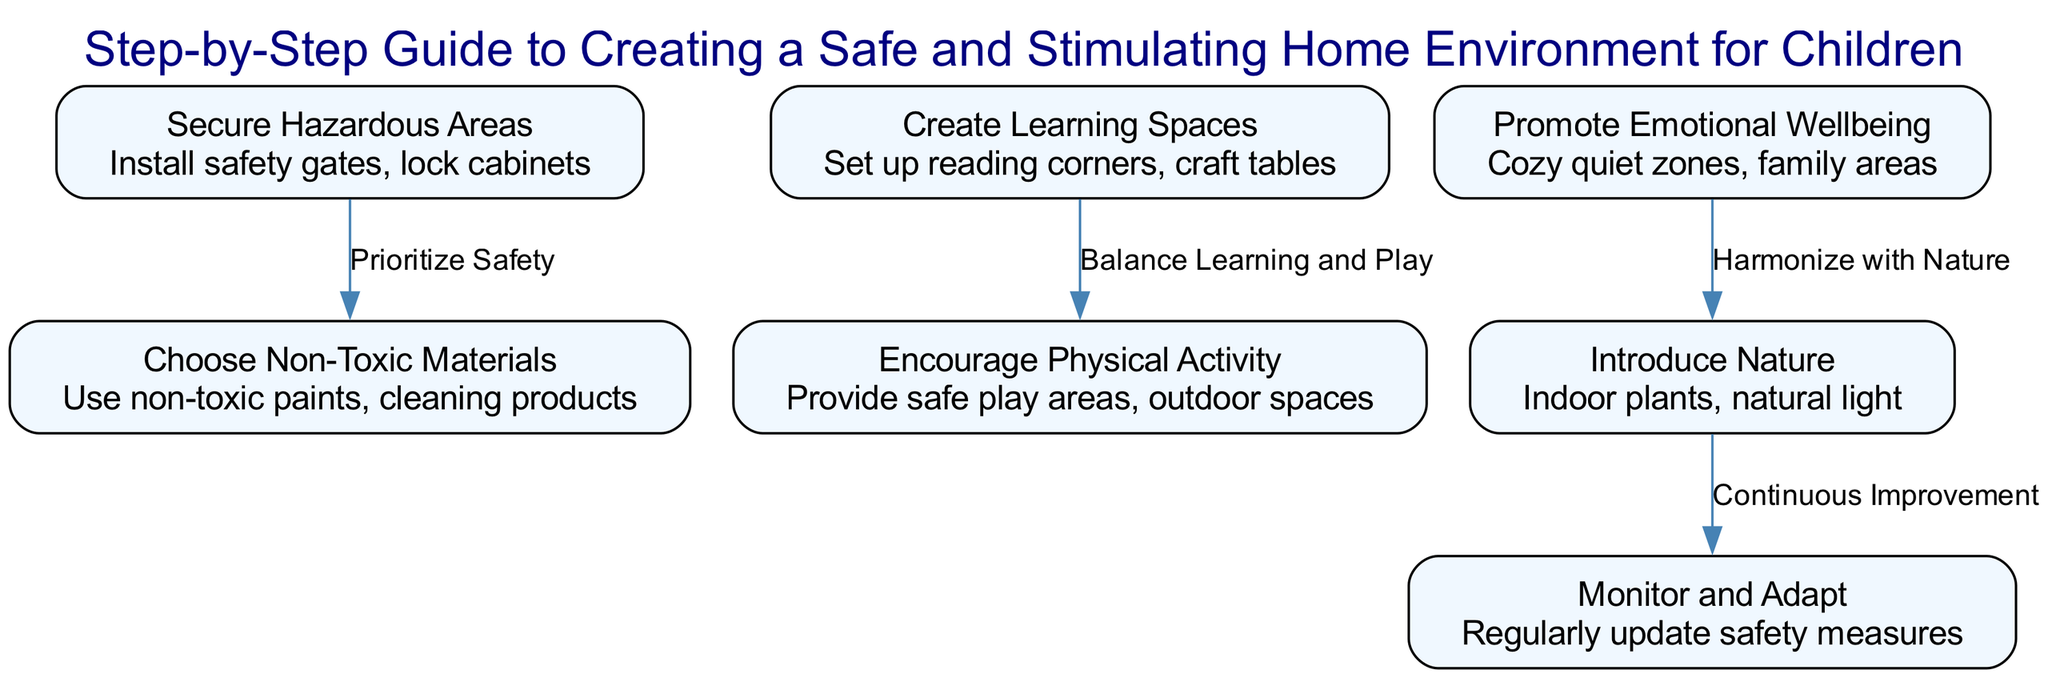What is the first step in creating a safe home environment for children? The diagram indicates that the first step is "Secure Hazardous Areas," which involves installing safety gates and locking cabinets to ensure safety.
Answer: Secure Hazardous Areas How many total nodes are present in the diagram? The diagram lists seven distinct nodes associated with creating a safe and stimulating home environment for children.
Answer: Seven What does the edge between "Promote Emotional Wellbeing" and "Introduce Nature" represent? The diagram shows that the relationship between these two nodes is characterized by the phrase "Harmonize with Nature," suggesting that emotional wellbeing can be enhanced by incorporating nature.
Answer: Harmonize with Nature What is one of the details under "Create Learning Spaces"? The details provided include "Set up reading corners" and "craft tables," which are key elements for enhancing children's learning.
Answer: Set up reading corners What is the last step mentioned in the steps to ensure a safe environment? According to the diagram, the last step is "Monitor and Adapt," which emphasizes the importance of regularly updating safety measures to align with children's needs.
Answer: Monitor and Adapt How do “Choose Non-Toxic Materials” and “Secure Hazardous Areas” relate to each other? The edge connecting these two nodes indicates that they are linked through the concept of "Prioritize Safety," reflecting the overall goal of maintaining a safe environment.
Answer: Prioritize Safety Which node emphasizes the importance of outdoor spaces? The diagram notes "Encourage Physical Activity," which specifically addresses providing safe play areas and outdoor spaces for children’s physical development.
Answer: Encourage Physical Activity What is one key detail included in "Introduce Nature"? This node suggests the incorporation of "Indoor plants" and "natural light," both essential for creating a connection with nature within the home environment.
Answer: Indoor plants What is the relationship between "Create Learning Spaces" and "Encourage Physical Activity"? The diagram identifies that these two elements are connected through "Balance Learning and Play," indicating the need to find a harmony between the two.
Answer: Balance Learning and Play 